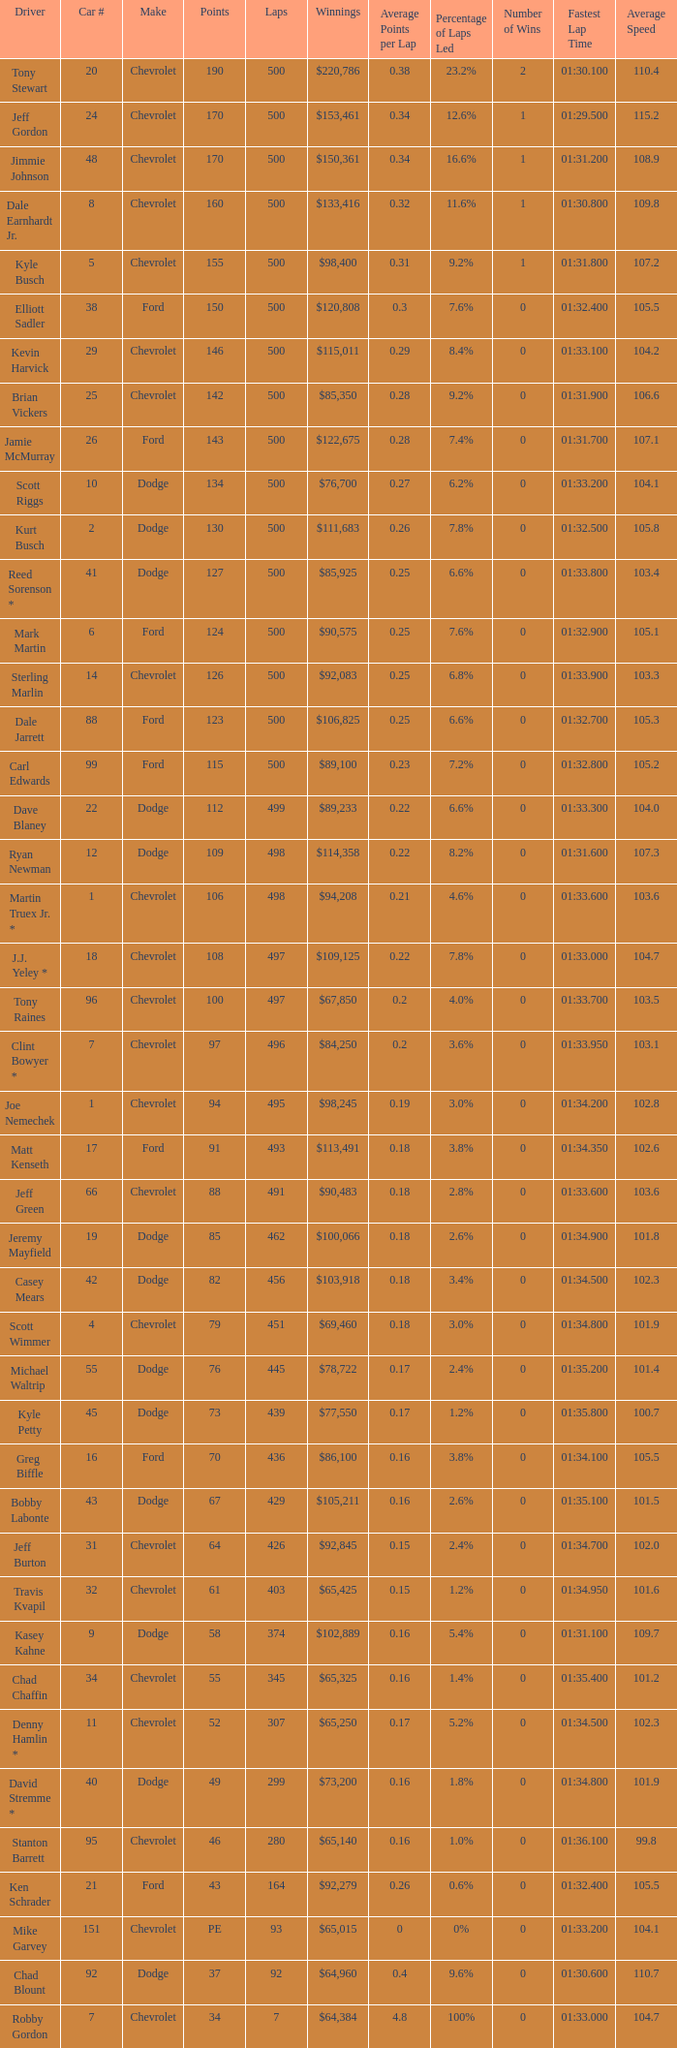What make of car did Brian Vickers drive? Chevrolet. 